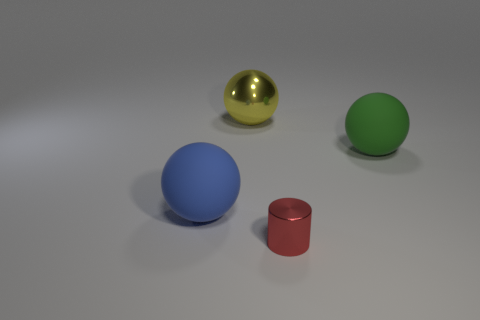Are there any other things that have the same size as the metallic cylinder?
Your response must be concise. No. Is there anything else that has the same shape as the small red thing?
Give a very brief answer. No. Are there fewer rubber balls behind the red metallic cylinder than objects that are on the left side of the green object?
Your answer should be compact. Yes. Are there fewer big yellow metallic balls in front of the green sphere than red cylinders?
Give a very brief answer. Yes. What is the material of the big sphere in front of the matte sphere on the right side of the matte thing on the left side of the big shiny object?
Ensure brevity in your answer.  Rubber. What number of things are objects behind the red metallic thing or large balls in front of the large green sphere?
Your answer should be very brief. 3. What material is the big green object that is the same shape as the big yellow shiny object?
Provide a short and direct response. Rubber. What number of shiny things are either big spheres or purple objects?
Provide a succinct answer. 1. There is a yellow object that is made of the same material as the cylinder; what shape is it?
Give a very brief answer. Sphere. What number of yellow things have the same shape as the big blue matte object?
Offer a terse response. 1. 